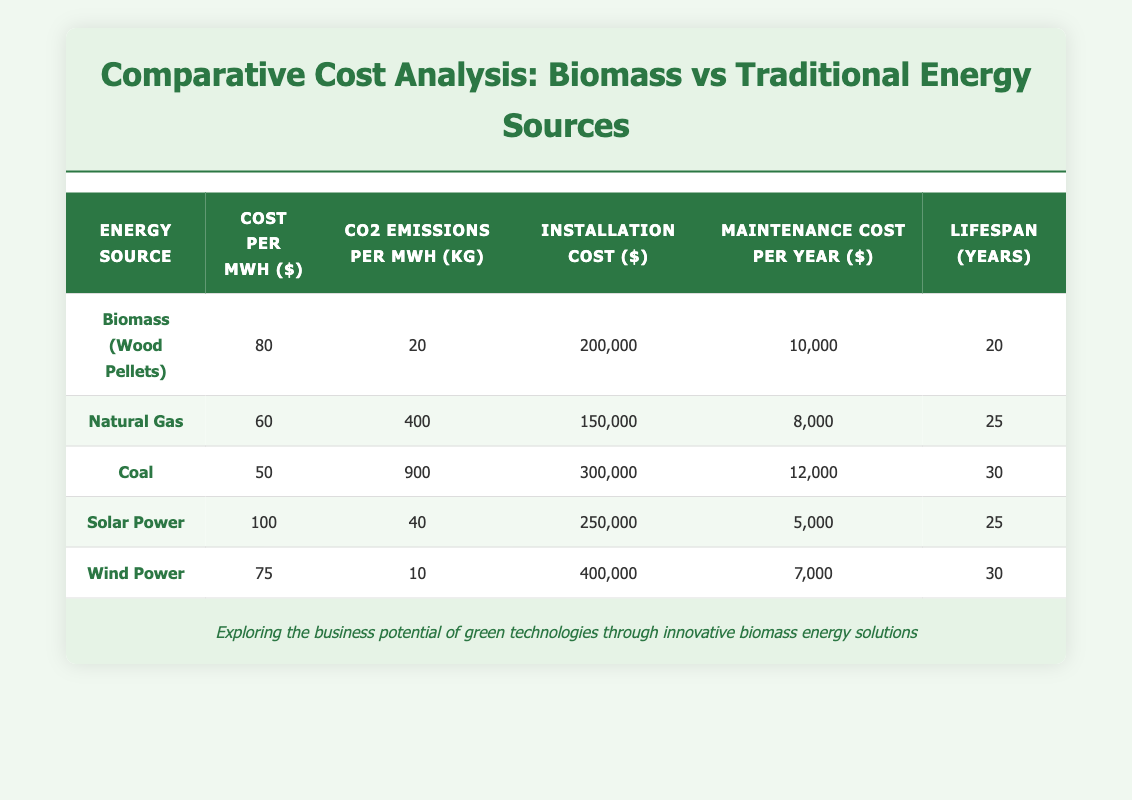What is the cost per MWh for biomass (wood pellets)? The table lists the cost per MWh for biomass (wood pellets) directly under the "Cost per MWh" column. The value given is 80 dollars.
Answer: 80 Which energy source has the highest CO2 emissions per MWh? By comparing the values in the "CO2 Emissions per MWh" column, coal has the highest emissions at 900 kg per MWh.
Answer: Coal What is the average maintenance cost per year among all energy sources? To find the average maintenance cost, sum all the maintenance costs: (10000 + 8000 + 12000 + 5000 + 7000) = 43000. There are 5 energy sources, so the average is 43000 / 5 = 8600.
Answer: 8600 Is the installation cost of solar power less than that of natural gas? The installation cost for solar power is 250000, while for natural gas it is 150000. Therefore, solar power's installation cost is greater than natural gas.
Answer: No What is the total installation cost if we consider only biomass and coal? The installation cost for biomass is 200000 and for coal it is 300000. Summing these gives a total of 200000 + 300000 = 500000.
Answer: 500000 Which energy source has the longest lifespan? The lifespan values are 20 years for biomass, 25 years for natural gas and solar power, and 30 years for coal and wind power. Both coal and wind power share the longest lifespan of 30 years.
Answer: Coal and Wind Power What is the difference in CO2 emissions per MWh between wind power and biomass? The CO2 emissions for wind power are 10 kg per MWh, while for biomass they are 20 kg per MWh. The difference is 20 - 10 = 10 kg per MWh.
Answer: 10 Is the maintenance cost per year for coal higher than that for biomass? The maintenance cost for coal is 12000, while for biomass it is 10000. Since 12000 is greater than 10000, the statement is true.
Answer: Yes What is the total cost (installation + maintenance cost over a lifespan) for natural gas? The total cost for natural gas is calculated as follows: Installation cost is 150000 and the maintenance cost per year is 8000 over its lifespan of 25 years, so total maintenance is 8000 * 25 = 200000. The total cost is 150000 + 200000 = 350000.
Answer: 350000 